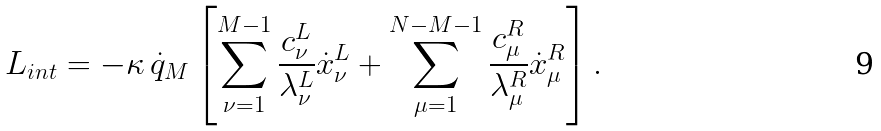Convert formula to latex. <formula><loc_0><loc_0><loc_500><loc_500>L _ { i n t } = - \kappa \, \dot { q } _ { M } \left [ \sum _ { \nu = 1 } ^ { M - 1 } \frac { c _ { \nu } ^ { L } } { \lambda _ { \nu } ^ { L } } \dot { x } _ { \nu } ^ { L } + \sum _ { \mu = 1 } ^ { N - M - 1 } \frac { c _ { \mu } ^ { R } } { \lambda _ { \mu } ^ { R } } \dot { x } _ { \mu } ^ { R } \right ] .</formula> 